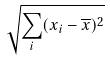Convert formula to latex. <formula><loc_0><loc_0><loc_500><loc_500>\sqrt { \sum _ { i } ( x _ { i } - \overline { x } ) ^ { 2 } }</formula> 